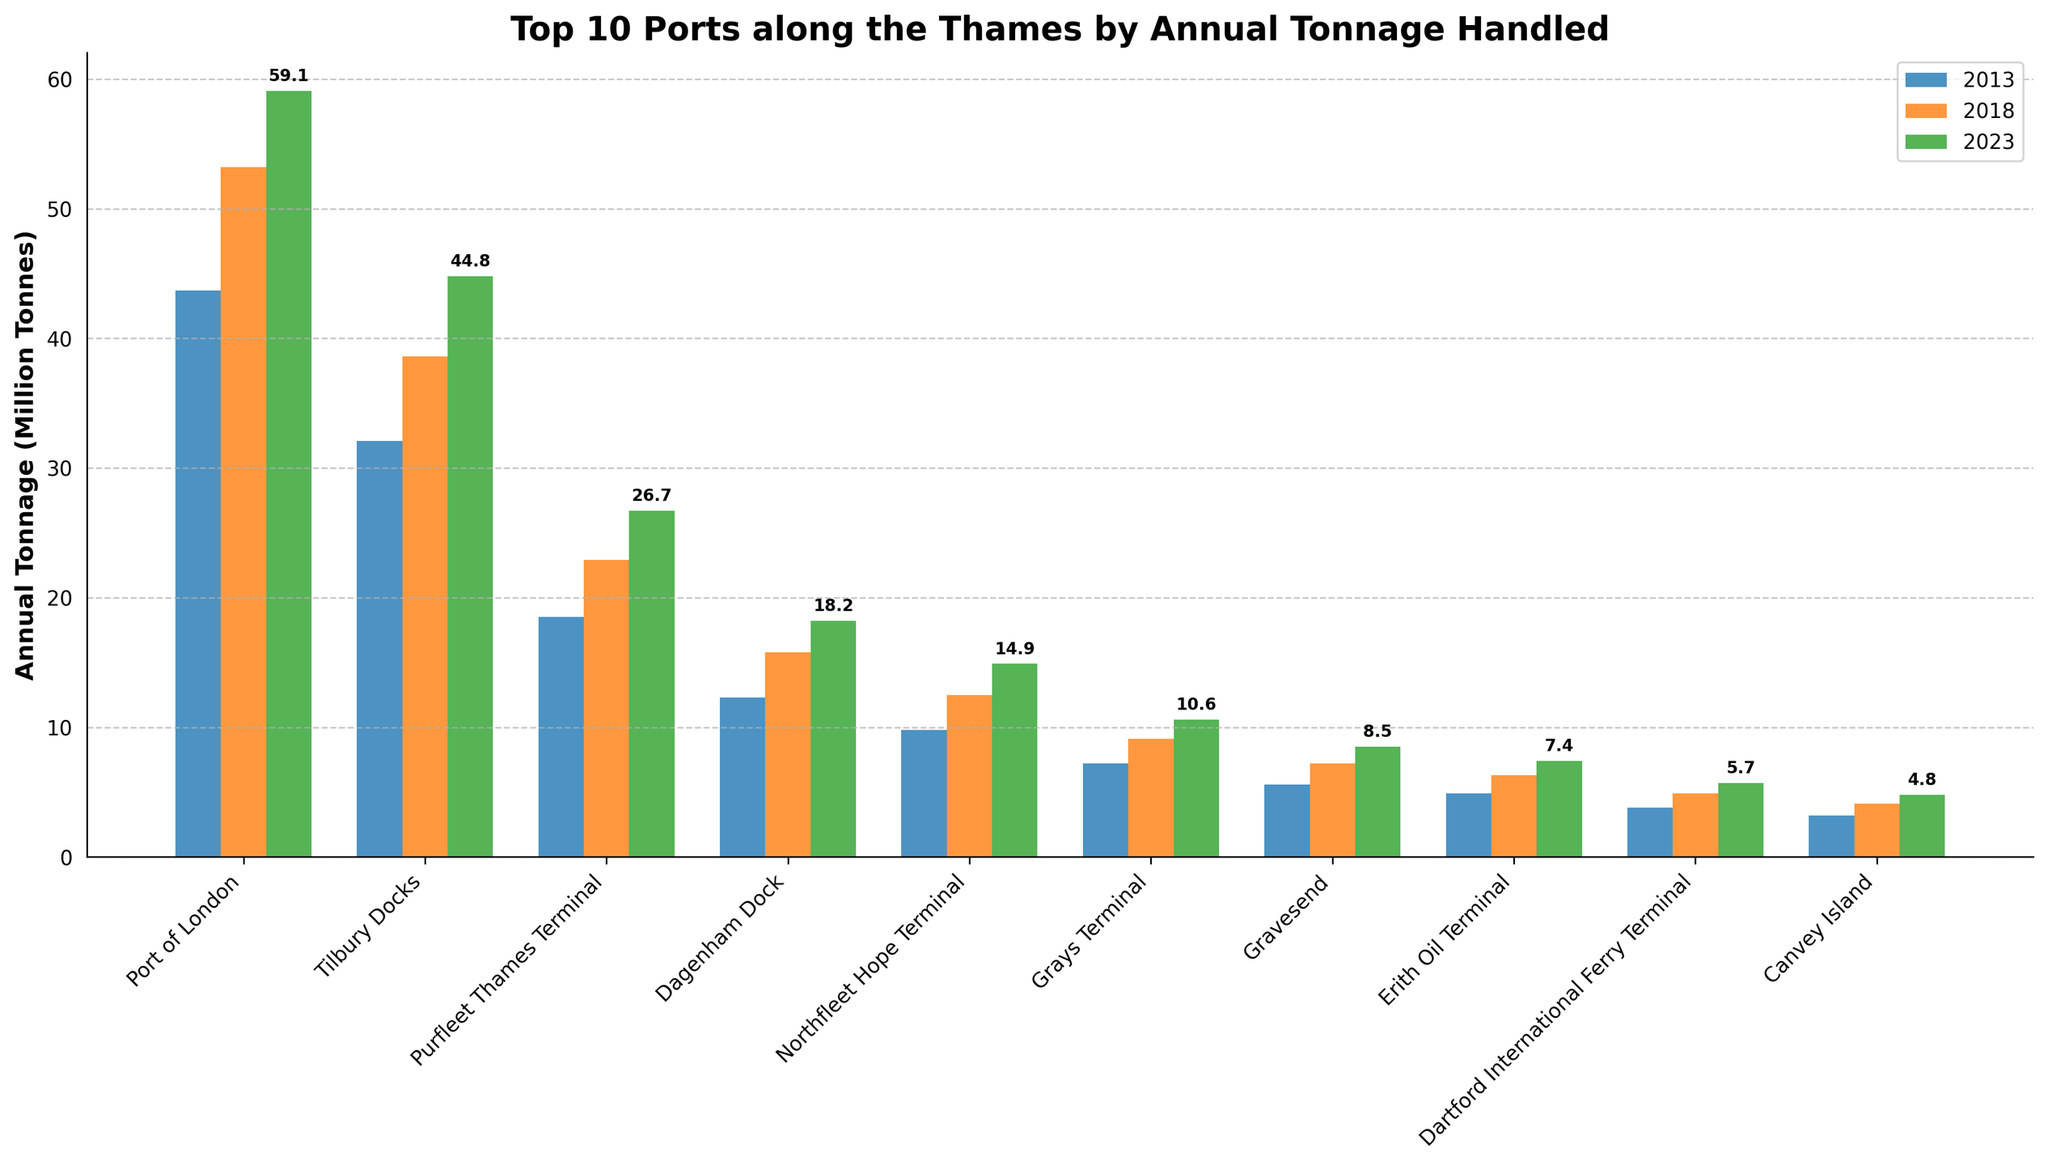Which port had the highest annual tonnage handled in 2023? Look at the bars labeled for 2023 and find the tallest one. The tallest bar belongs to the Port of London.
Answer: Port of London Which port showed the largest increase in tonnage from 2013 to 2023? Calculate the difference between 2023 and 2013 for each port. The differences are as follows: Port of London (15.4), Tilbury Docks (12.7), Purfleet Thames Terminal (8.2), Dagenham Dock (5.9), Northfleet Hope Terminal (5.1), Grays Terminal (3.4), Gravesend (2.9), Erith Oil Terminal (2.5), Dartford International Ferry Terminal (1.9), and Canvey Island (1.6). The largest increase is for the Port of London.
Answer: Port of London Which ports had an increase in tonnage every measured year (2013, 2018, 2023)? Check each port's tonnage for 2013, 2018, and 2023 to see if the values consistently increase. All ports show a consistent increase.
Answer: All ports What is the average annual tonnage handled by Tilbury Docks over the three years? Sum Tilbury Docks' annual tonnage for 2013, 2018, and 2023 (32.1 + 38.6 + 44.8 = 115.5) and divide by 3.
Answer: 38.5 Compare the tonnage handled by Purfleet Thames Terminal and Northfleet Hope Terminal in 2023. Which is greater and by how much? Purfleet Thames Terminal had 26.7 million tonnes and Northfleet Hope Terminal had 14.9 million tonnes in 2023. Subtract Northfleet Hope Terminal's tonnage from Purfleet Thames Terminal's tonnage (26.7 - 14.9).
Answer: Purfleet Thames Terminal by 11.8 million tonnes Which port had the smallest tonnage in 2013 and what was it? Look at the bars labeled for 2013 and find the shortest one. The shortest bar belongs to Canvey Island with a tonnage of 3.2 million tonnes.
Answer: Canvey Island, 3.2 million tonnes What is the difference in tonnage between the largest and smallest ports in 2023? Find the tonnage for the largest port (Port of London: 59.1) and the smallest port (Canvey Island: 4.8) in 2023 and subtract the smallest from the largest (59.1 - 4.8).
Answer: 54.3 million tonnes Which port had the highest increase in tonnage between 2018 and 2023? Calculate the difference between 2023 and 2018 for each port. The differences are as follows: Port of London (5.9), Tilbury Docks (6.2), Purfleet Thames Terminal (3.8), Dagenham Dock (2.4), Northfleet Hope Terminal (2.4), Grays Terminal (1.5), Gravesend (1.3), Erith Oil Terminal (1.1), Dartford International Ferry Terminal (0.8), Canvey Island (0.7). The highest increase is for Tilbury Docks.
Answer: Tilbury Docks 